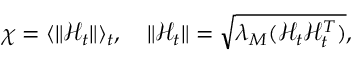Convert formula to latex. <formula><loc_0><loc_0><loc_500><loc_500>\begin{array} { r } { \chi = \langle \| \mathcal { H } _ { t } \| \rangle _ { t } , \quad \| \mathcal { H } _ { t } \| = \sqrt { \lambda _ { M } ( \mathcal { H } _ { t } \mathcal { H } _ { t } ^ { T } ) } , } \end{array}</formula> 